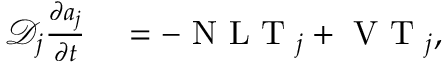<formula> <loc_0><loc_0><loc_500><loc_500>\begin{array} { r l } { \mathcal { D } _ { j } \frac { \partial a _ { j } } { \partial t } } & = - N L T _ { j } + V T _ { j } , } \end{array}</formula> 